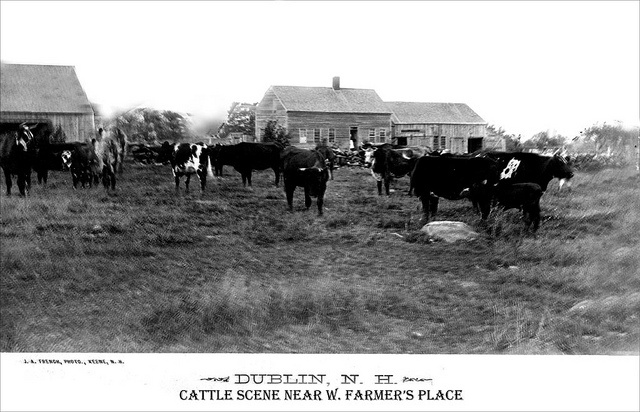Describe the objects in this image and their specific colors. I can see cow in darkgray, black, gray, and lightgray tones, cow in darkgray, black, gray, and lightgray tones, cow in darkgray, black, gray, and lightgray tones, cow in darkgray, black, gray, and lightgray tones, and cow in darkgray, black, gray, and lightgray tones in this image. 